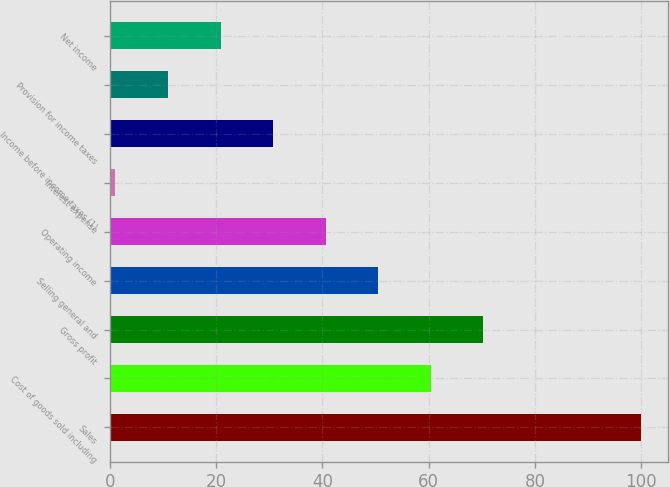Convert chart to OTSL. <chart><loc_0><loc_0><loc_500><loc_500><bar_chart><fcel>Sales<fcel>Cost of goods sold including<fcel>Gross profit<fcel>Selling general and<fcel>Operating income<fcel>Interest expense<fcel>Income before income taxes (1)<fcel>Provision for income taxes<fcel>Net income<nl><fcel>100<fcel>60.4<fcel>70.3<fcel>50.5<fcel>40.6<fcel>1<fcel>30.7<fcel>10.9<fcel>20.8<nl></chart> 